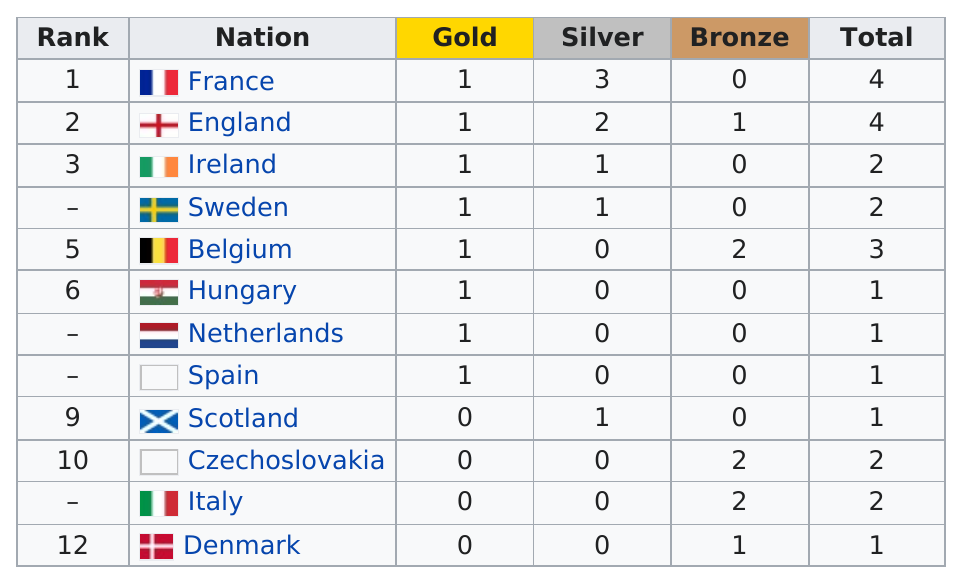Outline some significant characteristics in this image. Eight different countries have won gold medals. The nation of France did not earn a bronze medal in the most recent Olympic Games. Of the countries that have earned the least amount of medals overall, five are among the least. In the Olympics, how many nations received at least 3 medals total? 3... The total number of medals given is 24. 